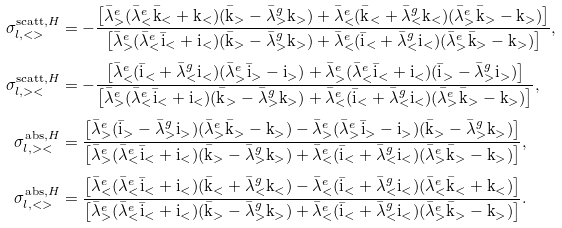Convert formula to latex. <formula><loc_0><loc_0><loc_500><loc_500>\sigma ^ { \text {scatt} , H } _ { l , < > } & = - \frac { \left [ { \bar { \lambda } } ^ { e } _ { > } ( { \bar { \lambda } } ^ { e } _ { < } \bar { \text {k} } _ { < } + \text {k} _ { < } ) ( \bar { \text {k} } _ { > } - { \bar { \lambda } } ^ { g } _ { > } \text {k} _ { > } ) + { \bar { \lambda } } ^ { e } _ { < } ( \bar { \text {k} } _ { < } + { \bar { \lambda } } ^ { g } _ { < } \text {k} _ { < } ) ( { \bar { \lambda } } ^ { e } _ { > } \bar { \text {k} } _ { > } - \text {k} _ { > } ) \right ] } { \left [ { \bar { \lambda } } ^ { e } _ { > } ( { \bar { \lambda } } ^ { e } _ { < } \bar { \text {i} } _ { < } + \text {i} _ { < } ) ( \bar { \text {k} } _ { > } - { \bar { \lambda } } ^ { g } _ { > } \text {k} _ { > } ) + { \bar { \lambda } } ^ { e } _ { < } ( \bar { \text {i} } _ { < } + { \bar { \lambda } } ^ { g } _ { < } \text {i} _ { < } ) ( { \bar { \lambda } } ^ { e } _ { > } \bar { \text {k} } _ { > } - \text {k} _ { > } ) \right ] } , \\ \sigma ^ { \text {scatt} , H } _ { l , > < } & = - \frac { \left [ { \bar { \lambda } } ^ { e } _ { < } ( \bar { \text {i} } _ { < } + { \bar { \lambda } } ^ { g } _ { < } \text {i} _ { < } ) ( { \bar { \lambda } } ^ { e } _ { > } \bar { \text {i} } _ { > } - \text {i} _ { > } ) + { \bar { \lambda } } ^ { e } _ { > } ( { \bar { \lambda } } ^ { e } _ { < } \bar { \text {i} } _ { < } + \text {i} _ { < } ) ( \bar { \text {i} } _ { > } - { \bar { \lambda } } ^ { g } _ { > } \text {i} _ { > } ) \right ] } { \left [ { \bar { \lambda } } ^ { e } _ { > } ( { \bar { \lambda } } ^ { e } _ { < } \bar { \text {i} } _ { < } + \text {i} _ { < } ) ( \bar { \text {k} } _ { > } - { \bar { \lambda } } ^ { g } _ { > } \text {k} _ { > } ) + { \bar { \lambda } } ^ { e } _ { < } ( \bar { \text {i} } _ { < } + { \bar { \lambda } } ^ { g } _ { < } \text {i} _ { < } ) ( { \bar { \lambda } } ^ { e } _ { > } \bar { \text {k} } _ { > } - \text {k} _ { > } ) \right ] } , \\ \sigma ^ { \text {abs} , H } _ { l , > < } & = \frac { \left [ { \bar { \lambda } } ^ { e } _ { > } ( \bar { \text {i} } _ { > } - { \bar { \lambda } } ^ { g } _ { > } \text {i} _ { > } ) ( { \bar { \lambda } } ^ { e } _ { > } \bar { \text {k} } _ { > } - \text {k} _ { > } ) - { \bar { \lambda } } ^ { e } _ { > } ( { \bar { \lambda } } ^ { e } _ { > } \bar { \text {i} } _ { > } - \text {i} _ { > } ) ( \bar { \text {k} } _ { > } - { \bar { \lambda } } ^ { g } _ { > } \text {k} _ { > } ) \right ] } { \left [ { \bar { \lambda } } ^ { e } _ { > } ( { \bar { \lambda } } ^ { e } _ { < } \bar { \text {i} } _ { < } + \text {i} _ { < } ) ( \bar { \text {k} } _ { > } - { \bar { \lambda } } ^ { g } _ { > } \text {k} _ { > } ) + { \bar { \lambda } } ^ { e } _ { < } ( \bar { \text {i} } _ { < } + { \bar { \lambda } } ^ { g } _ { < } \text {i} _ { < } ) ( { \bar { \lambda } } ^ { e } _ { > } \bar { \text {k} } _ { > } - \text {k} _ { > } ) \right ] } , \\ \sigma ^ { \text {abs} , H } _ { l , < > } & = \frac { \left [ { \bar { \lambda } } ^ { e } _ { < } ( { \bar { \lambda } } ^ { e } _ { < } \bar { \text {i} } _ { < } + \text {i} _ { < } ) ( \bar { \text {k} } _ { < } + { \bar { \lambda } } ^ { g } _ { < } \text {k} _ { < } ) - { \bar { \lambda } } ^ { e } _ { < } ( \bar { \text {i} } _ { < } + { \bar { \lambda } } ^ { g } _ { < } \text {i} _ { < } ) ( { \bar { \lambda } } ^ { e } _ { < } \bar { \text {k} } _ { < } + \text {k} _ { < } ) \right ] } { \left [ { \bar { \lambda } } ^ { e } _ { > } ( { \bar { \lambda } } ^ { e } _ { < } \bar { \text {i} } _ { < } + \text {i} _ { < } ) ( \bar { \text {k} } _ { > } - { \bar { \lambda } } ^ { g } _ { > } \text {k} _ { > } ) + { \bar { \lambda } } ^ { e } _ { < } ( \bar { \text {i} } _ { < } + { \bar { \lambda } } ^ { g } _ { < } \text {i} _ { < } ) ( { \bar { \lambda } } ^ { e } _ { > } \bar { \text {k} } _ { > } - \text {k} _ { > } ) \right ] } .</formula> 